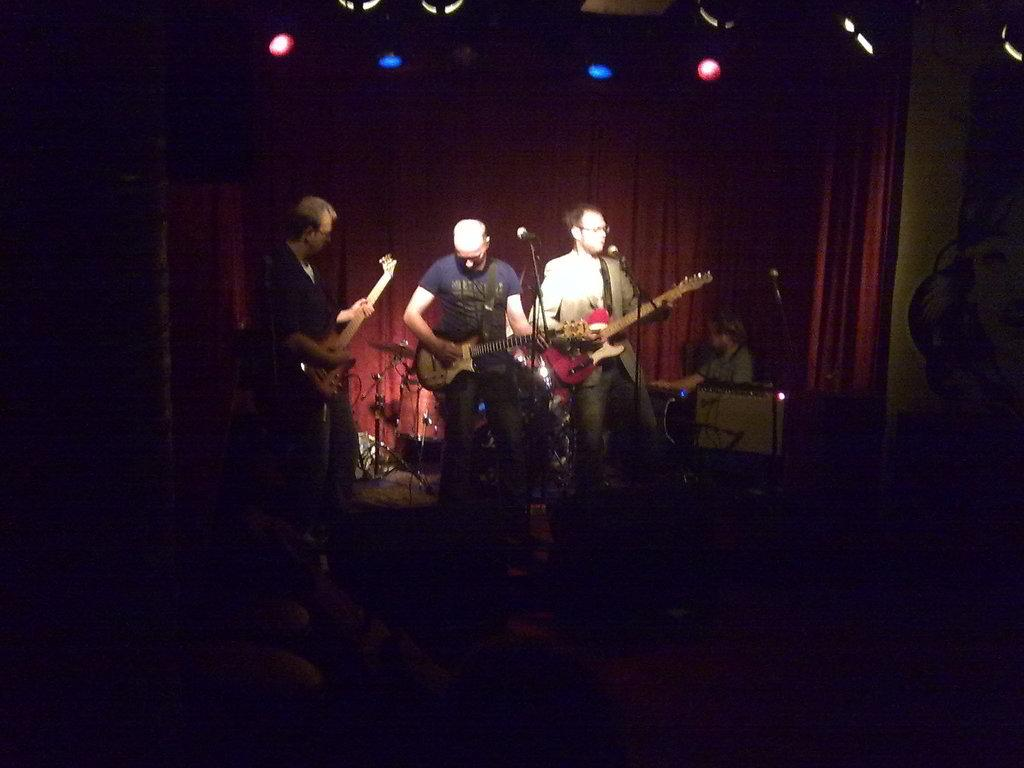How many people are in the image? There are people in the image, but the exact number is not specified. What are the people doing in the image? The people are standing in the image. What object are the people holding in their hands? The people are holding a guitar in their hands. What type of art can be seen on the guitar in the image? There is no information about any art on the guitar in the image. What kind of ink is used to write the lyrics on the guitar in the image? There is no mention of any lyrics or ink on the guitar in the image. 